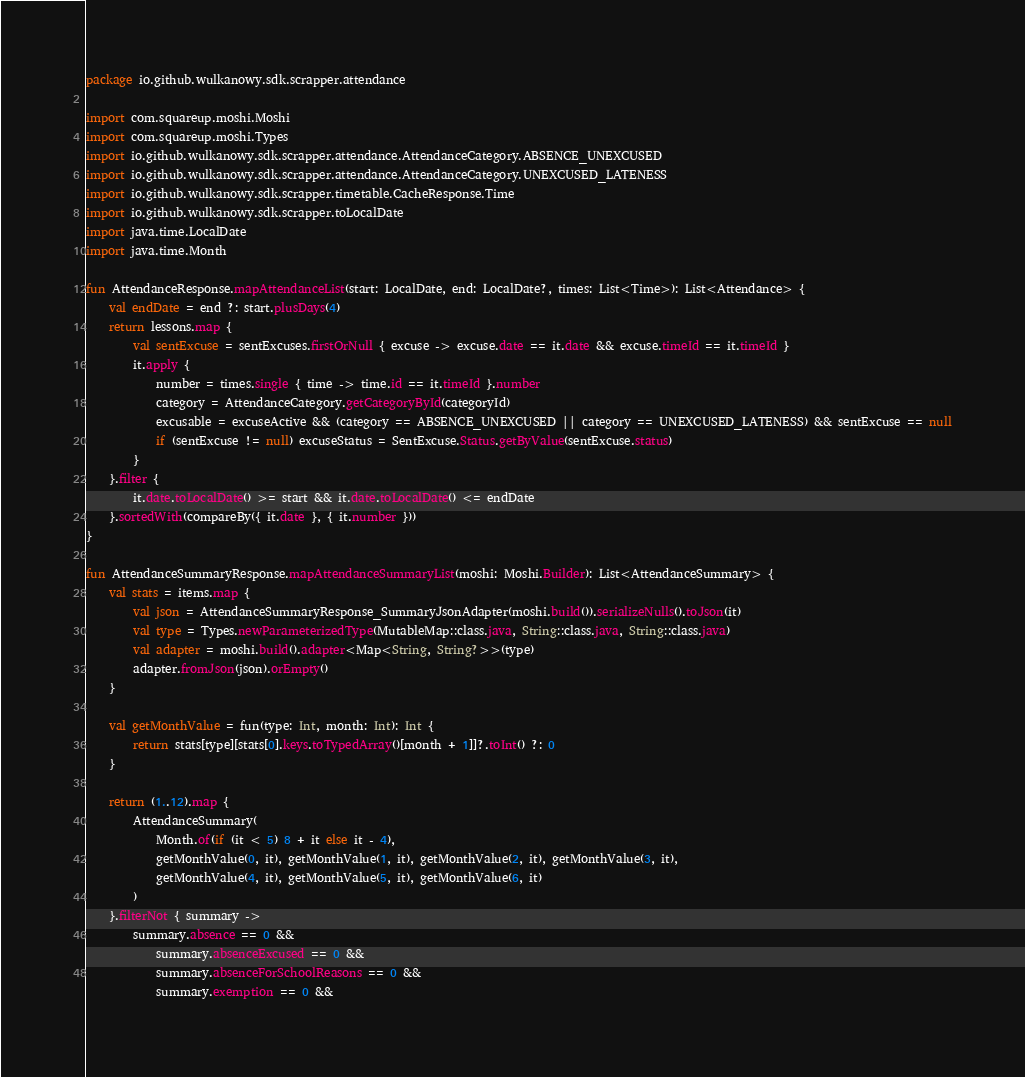Convert code to text. <code><loc_0><loc_0><loc_500><loc_500><_Kotlin_>package io.github.wulkanowy.sdk.scrapper.attendance

import com.squareup.moshi.Moshi
import com.squareup.moshi.Types
import io.github.wulkanowy.sdk.scrapper.attendance.AttendanceCategory.ABSENCE_UNEXCUSED
import io.github.wulkanowy.sdk.scrapper.attendance.AttendanceCategory.UNEXCUSED_LATENESS
import io.github.wulkanowy.sdk.scrapper.timetable.CacheResponse.Time
import io.github.wulkanowy.sdk.scrapper.toLocalDate
import java.time.LocalDate
import java.time.Month

fun AttendanceResponse.mapAttendanceList(start: LocalDate, end: LocalDate?, times: List<Time>): List<Attendance> {
    val endDate = end ?: start.plusDays(4)
    return lessons.map {
        val sentExcuse = sentExcuses.firstOrNull { excuse -> excuse.date == it.date && excuse.timeId == it.timeId }
        it.apply {
            number = times.single { time -> time.id == it.timeId }.number
            category = AttendanceCategory.getCategoryById(categoryId)
            excusable = excuseActive && (category == ABSENCE_UNEXCUSED || category == UNEXCUSED_LATENESS) && sentExcuse == null
            if (sentExcuse != null) excuseStatus = SentExcuse.Status.getByValue(sentExcuse.status)
        }
    }.filter {
        it.date.toLocalDate() >= start && it.date.toLocalDate() <= endDate
    }.sortedWith(compareBy({ it.date }, { it.number }))
}

fun AttendanceSummaryResponse.mapAttendanceSummaryList(moshi: Moshi.Builder): List<AttendanceSummary> {
    val stats = items.map {
        val json = AttendanceSummaryResponse_SummaryJsonAdapter(moshi.build()).serializeNulls().toJson(it)
        val type = Types.newParameterizedType(MutableMap::class.java, String::class.java, String::class.java)
        val adapter = moshi.build().adapter<Map<String, String?>>(type)
        adapter.fromJson(json).orEmpty()
    }

    val getMonthValue = fun(type: Int, month: Int): Int {
        return stats[type][stats[0].keys.toTypedArray()[month + 1]]?.toInt() ?: 0
    }

    return (1..12).map {
        AttendanceSummary(
            Month.of(if (it < 5) 8 + it else it - 4),
            getMonthValue(0, it), getMonthValue(1, it), getMonthValue(2, it), getMonthValue(3, it),
            getMonthValue(4, it), getMonthValue(5, it), getMonthValue(6, it)
        )
    }.filterNot { summary ->
        summary.absence == 0 &&
            summary.absenceExcused == 0 &&
            summary.absenceForSchoolReasons == 0 &&
            summary.exemption == 0 &&</code> 